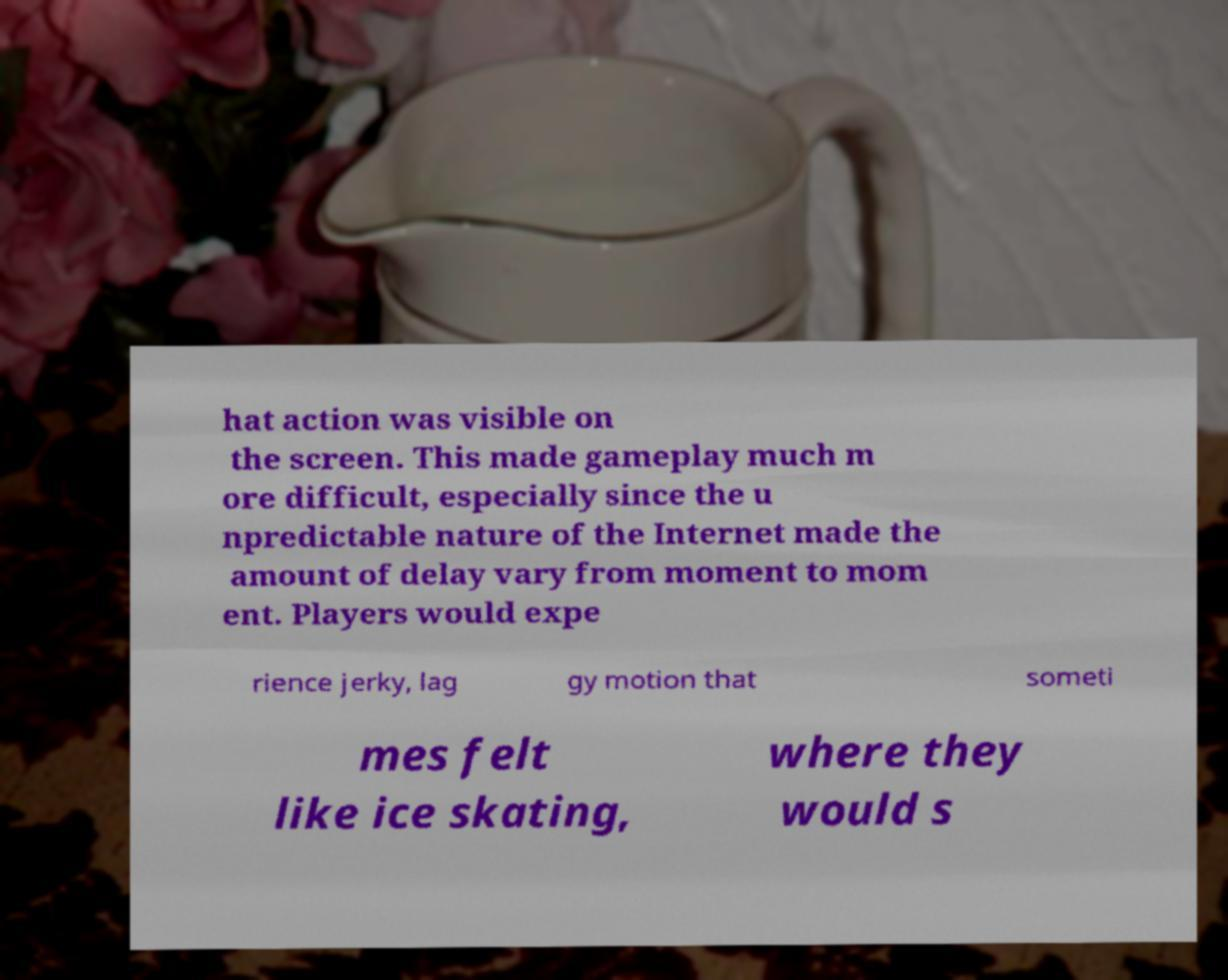There's text embedded in this image that I need extracted. Can you transcribe it verbatim? hat action was visible on the screen. This made gameplay much m ore difficult, especially since the u npredictable nature of the Internet made the amount of delay vary from moment to mom ent. Players would expe rience jerky, lag gy motion that someti mes felt like ice skating, where they would s 